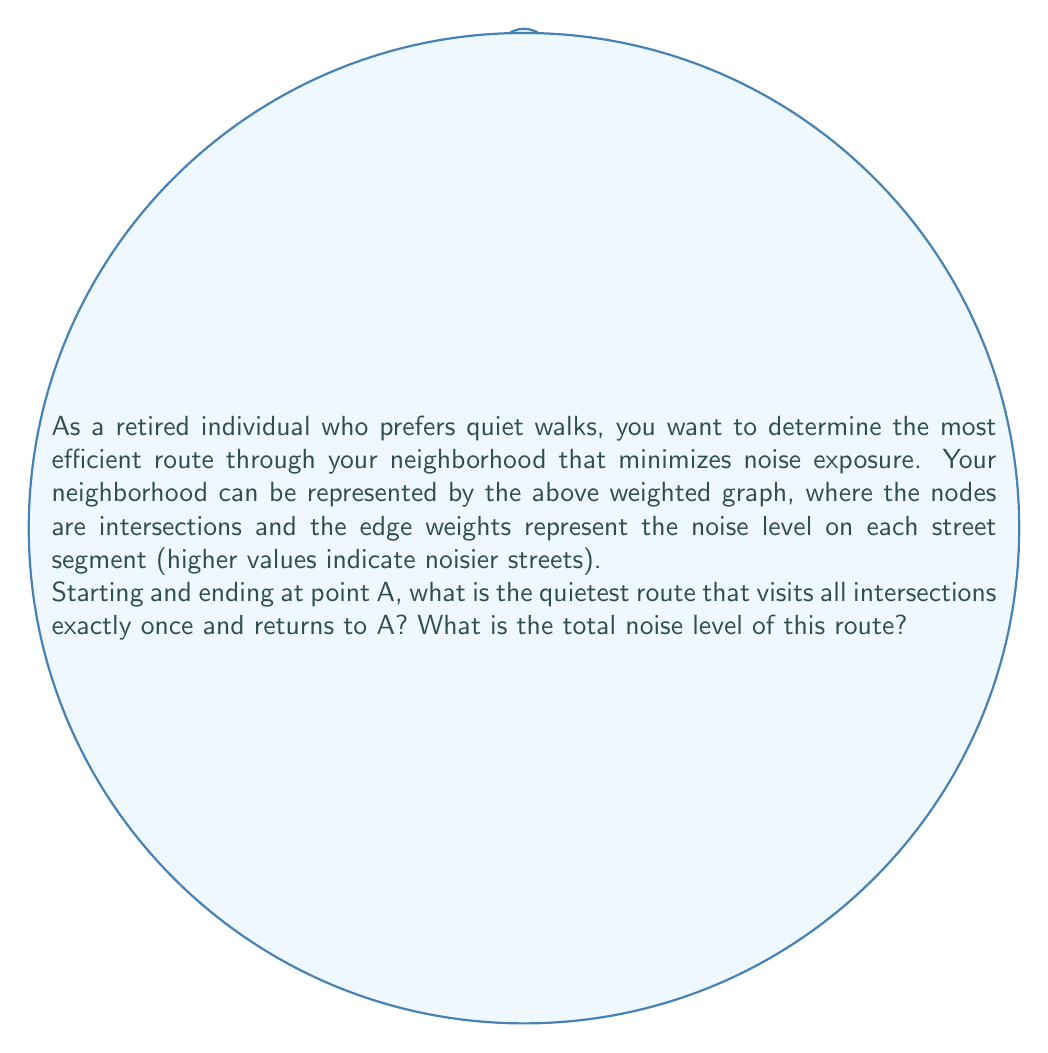Can you answer this question? To solve this problem, we can use the concept of the Traveling Salesman Problem (TSP) with the goal of minimizing the total noise level instead of distance.

Step 1: Identify all possible Hamiltonian cycles (routes that visit each node once and return to the starting point).
The possible cycles are:
1. A-B-C-D-A
2. A-B-D-C-A
3. A-D-B-C-A
4. A-D-C-B-A

Step 2: Calculate the total noise level for each cycle.

1. A-B-C-D-A:
   $3 + 2 + 4 + 5 = 14$

2. A-B-D-C-A:
   $3 + 1 + 4 + 2 = 10$

3. A-D-B-C-A:
   $5 + 1 + 2 + 3 = 11$

4. A-D-C-B-A:
   $5 + 4 + 2 + 3 = 14$

Step 3: Identify the cycle with the minimum total noise level.

The cycle with the lowest total noise level is A-B-D-C-A, with a total noise level of 10.

Therefore, the quietest route that visits all intersections exactly once and returns to A is A → B → D → C → A, and the total noise level of this route is 10.
Answer: Route: A-B-D-C-A; Total noise level: 10 